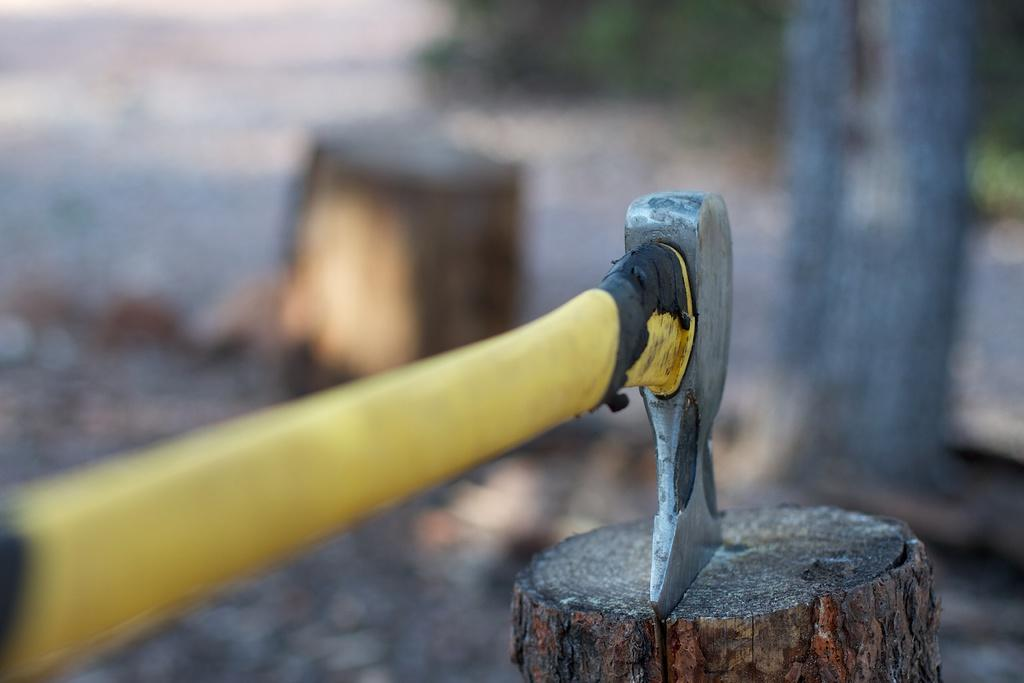What object can be seen in the image that is typically used for cutting or chopping? There is an axe in the image. What is the axe being used on in the image? There is a wooden log in the image. Can you describe the background of the image? The background of the image is blurred. What type of education is being taught in the image? There is no indication of education being taught in the image. What type of wilderness can be seen in the image? There is no wilderness visible in the image. 